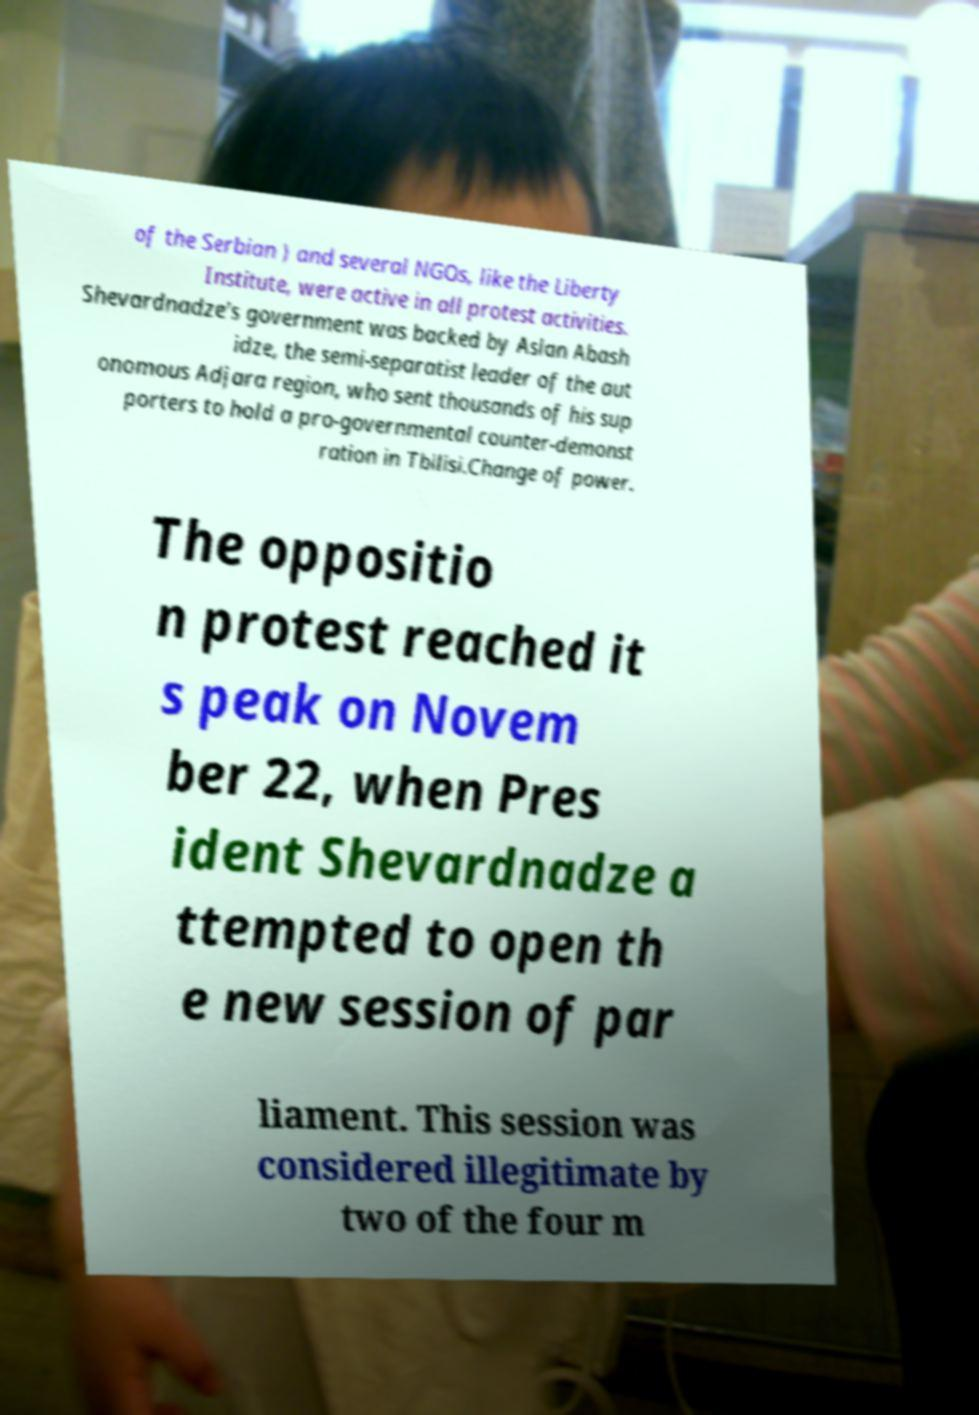Can you accurately transcribe the text from the provided image for me? of the Serbian ) and several NGOs, like the Liberty Institute, were active in all protest activities. Shevardnadze's government was backed by Aslan Abash idze, the semi-separatist leader of the aut onomous Adjara region, who sent thousands of his sup porters to hold a pro-governmental counter-demonst ration in Tbilisi.Change of power. The oppositio n protest reached it s peak on Novem ber 22, when Pres ident Shevardnadze a ttempted to open th e new session of par liament. This session was considered illegitimate by two of the four m 